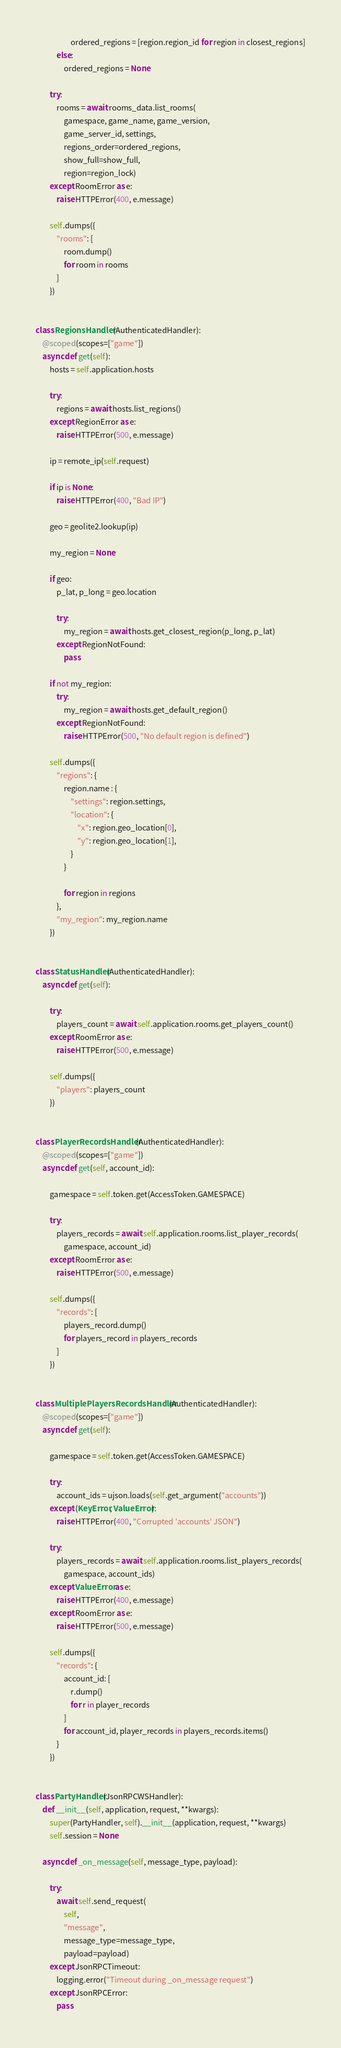Convert code to text. <code><loc_0><loc_0><loc_500><loc_500><_Python_>                    ordered_regions = [region.region_id for region in closest_regions]
            else:
                ordered_regions = None

        try:
            rooms = await rooms_data.list_rooms(
                gamespace, game_name, game_version,
                game_server_id, settings,
                regions_order=ordered_regions,
                show_full=show_full,
                region=region_lock)
        except RoomError as e:
            raise HTTPError(400, e.message)

        self.dumps({
            "rooms": [
                room.dump()
                for room in rooms
            ]
        })


class RegionsHandler(AuthenticatedHandler):
    @scoped(scopes=["game"])
    async def get(self):
        hosts = self.application.hosts

        try:
            regions = await hosts.list_regions()
        except RegionError as e:
            raise HTTPError(500, e.message)

        ip = remote_ip(self.request)

        if ip is None:
            raise HTTPError(400, "Bad IP")

        geo = geolite2.lookup(ip)

        my_region = None

        if geo:
            p_lat, p_long = geo.location

            try:
                my_region = await hosts.get_closest_region(p_long, p_lat)
            except RegionNotFound:
                pass

        if not my_region:
            try:
                my_region = await hosts.get_default_region()
            except RegionNotFound:
                raise HTTPError(500, "No default region is defined")

        self.dumps({
            "regions": {
                region.name : {
                    "settings": region.settings,
                    "location": {
                        "x": region.geo_location[0],
                        "y": region.geo_location[1],
                    }
                }

                for region in regions
            },
            "my_region": my_region.name
        })


class StatusHandler(AuthenticatedHandler):
    async def get(self):

        try:
            players_count = await self.application.rooms.get_players_count()
        except RoomError as e:
            raise HTTPError(500, e.message)

        self.dumps({
            "players": players_count
        })


class PlayerRecordsHandler(AuthenticatedHandler):
    @scoped(scopes=["game"])
    async def get(self, account_id):

        gamespace = self.token.get(AccessToken.GAMESPACE)

        try:
            players_records = await self.application.rooms.list_player_records(
                gamespace, account_id)
        except RoomError as e:
            raise HTTPError(500, e.message)

        self.dumps({
            "records": [
                players_record.dump()
                for players_record in players_records
            ]
        })


class MultiplePlayersRecordsHandler(AuthenticatedHandler):
    @scoped(scopes=["game"])
    async def get(self):

        gamespace = self.token.get(AccessToken.GAMESPACE)

        try:
            account_ids = ujson.loads(self.get_argument("accounts"))
        except (KeyError, ValueError):
            raise HTTPError(400, "Corrupted 'accounts' JSON")

        try:
            players_records = await self.application.rooms.list_players_records(
                gamespace, account_ids)
        except ValueError as e:
            raise HTTPError(400, e.message)
        except RoomError as e:
            raise HTTPError(500, e.message)

        self.dumps({
            "records": {
                account_id: [
                    r.dump()
                    for r in player_records
                ]
                for account_id, player_records in players_records.items()
            }
        })


class PartyHandler(JsonRPCWSHandler):
    def __init__(self, application, request, **kwargs):
        super(PartyHandler, self).__init__(application, request, **kwargs)
        self.session = None

    async def _on_message(self, message_type, payload):

        try:
            await self.send_request(
                self,
                "message",
                message_type=message_type,
                payload=payload)
        except JsonRPCTimeout:
            logging.error("Timeout during _on_message request")
        except JsonRPCError:
            pass
</code> 